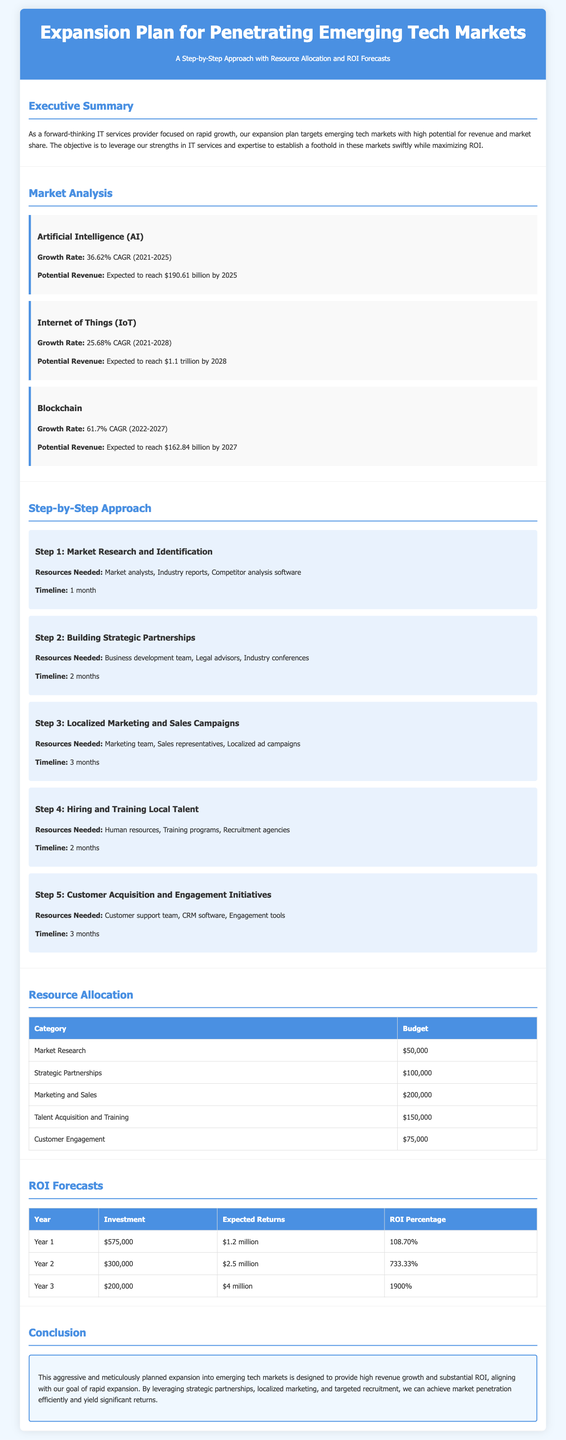What is the expected revenue of the AI market by 2025? The expected revenue of the AI market is stated in the Market Analysis section as $190.61 billion by 2025.
Answer: $190.61 billion What is the allocated budget for marketing and sales? The budget for marketing and sales is provided in the Resource Allocation section as $200,000.
Answer: $200,000 How long is the timeline for hiring and training local talent? The timeline for hiring and training local talent is mentioned in the Step-by-Step Approach section as 2 months.
Answer: 2 months What is the ROI percentage for Year 2? The ROI percentage for Year 2 is specified in the ROI Forecasts section as 733.33%.
Answer: 733.33% Which step involves building strategic partnerships? Building strategic partnerships is the focus of Step 2 in the Step-by-Step Approach section.
Answer: Step 2 What is the CAGR of the Blockchain market between 2022 and 2027? The CAGR of the Blockchain market is indicated in the Market Analysis section as 61.7%.
Answer: 61.7% How much is allocated for customer engagement in the Resource Allocation? The allocation for customer engagement is listed in the Resource Allocation section as $75,000.
Answer: $75,000 What is the total investment for Year 1? The total investment for Year 1 is detailed in the ROI Forecasts section as $575,000.
Answer: $575,000 What is the forecasted expected return for Year 3? The forecasted expected return for Year 3 is provided in the ROI Forecasts section as $4 million.
Answer: $4 million 